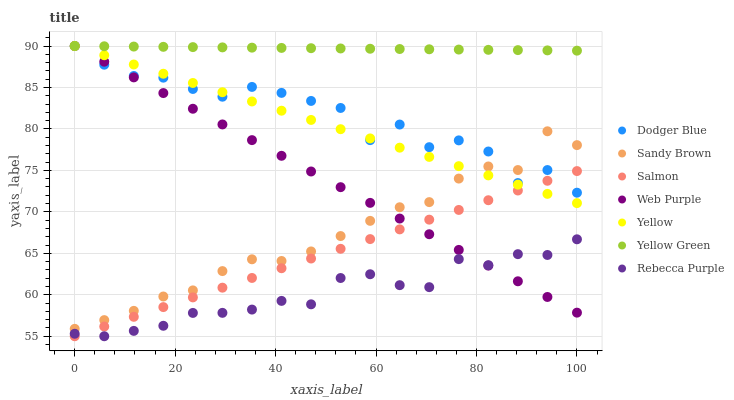Does Rebecca Purple have the minimum area under the curve?
Answer yes or no. Yes. Does Yellow Green have the maximum area under the curve?
Answer yes or no. Yes. Does Salmon have the minimum area under the curve?
Answer yes or no. No. Does Salmon have the maximum area under the curve?
Answer yes or no. No. Is Salmon the smoothest?
Answer yes or no. Yes. Is Dodger Blue the roughest?
Answer yes or no. Yes. Is Yellow the smoothest?
Answer yes or no. No. Is Yellow the roughest?
Answer yes or no. No. Does Salmon have the lowest value?
Answer yes or no. Yes. Does Yellow have the lowest value?
Answer yes or no. No. Does Dodger Blue have the highest value?
Answer yes or no. Yes. Does Salmon have the highest value?
Answer yes or no. No. Is Rebecca Purple less than Yellow Green?
Answer yes or no. Yes. Is Yellow Green greater than Salmon?
Answer yes or no. Yes. Does Yellow intersect Salmon?
Answer yes or no. Yes. Is Yellow less than Salmon?
Answer yes or no. No. Is Yellow greater than Salmon?
Answer yes or no. No. Does Rebecca Purple intersect Yellow Green?
Answer yes or no. No. 